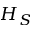Convert formula to latex. <formula><loc_0><loc_0><loc_500><loc_500>H _ { S }</formula> 